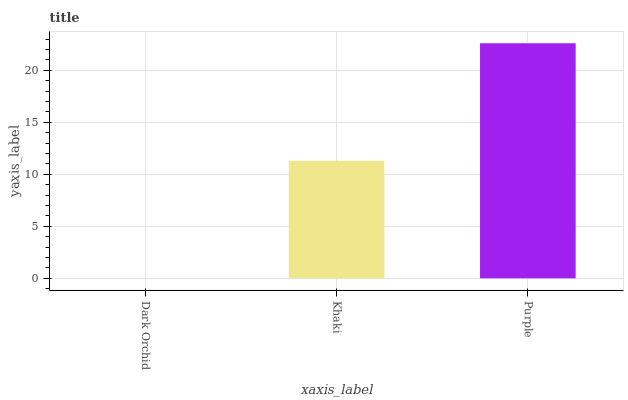Is Dark Orchid the minimum?
Answer yes or no. Yes. Is Purple the maximum?
Answer yes or no. Yes. Is Khaki the minimum?
Answer yes or no. No. Is Khaki the maximum?
Answer yes or no. No. Is Khaki greater than Dark Orchid?
Answer yes or no. Yes. Is Dark Orchid less than Khaki?
Answer yes or no. Yes. Is Dark Orchid greater than Khaki?
Answer yes or no. No. Is Khaki less than Dark Orchid?
Answer yes or no. No. Is Khaki the high median?
Answer yes or no. Yes. Is Khaki the low median?
Answer yes or no. Yes. Is Purple the high median?
Answer yes or no. No. Is Dark Orchid the low median?
Answer yes or no. No. 